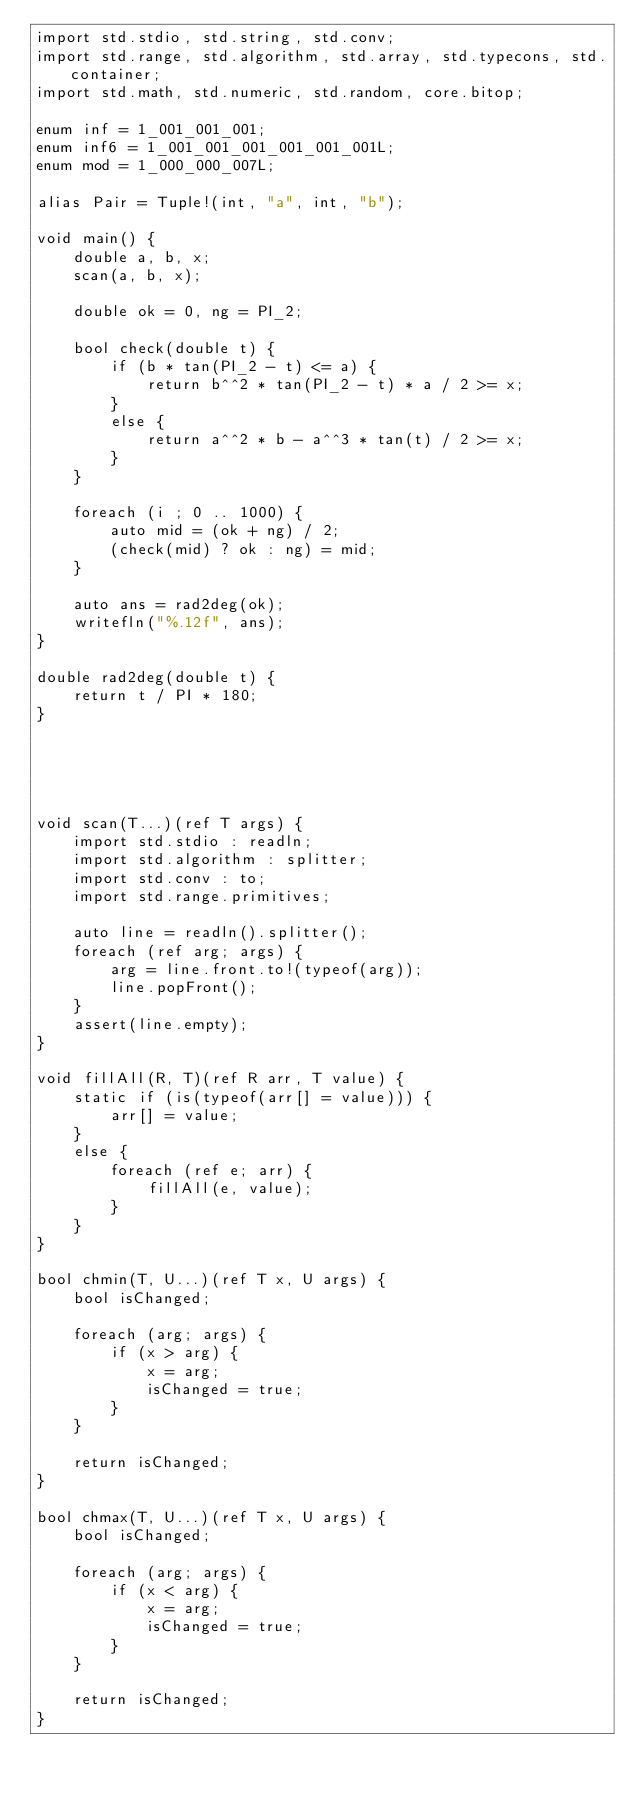Convert code to text. <code><loc_0><loc_0><loc_500><loc_500><_D_>import std.stdio, std.string, std.conv;
import std.range, std.algorithm, std.array, std.typecons, std.container;
import std.math, std.numeric, std.random, core.bitop;

enum inf = 1_001_001_001;
enum inf6 = 1_001_001_001_001_001_001L;
enum mod = 1_000_000_007L;

alias Pair = Tuple!(int, "a", int, "b");

void main() {
    double a, b, x;
    scan(a, b, x);

    double ok = 0, ng = PI_2;

    bool check(double t) {
        if (b * tan(PI_2 - t) <= a) {
            return b^^2 * tan(PI_2 - t) * a / 2 >= x;
        }
        else {
            return a^^2 * b - a^^3 * tan(t) / 2 >= x;
        }
    }

    foreach (i ; 0 .. 1000) {
        auto mid = (ok + ng) / 2;
        (check(mid) ? ok : ng) = mid;
    }

    auto ans = rad2deg(ok);
    writefln("%.12f", ans);
}

double rad2deg(double t) {
    return t / PI * 180;
}





void scan(T...)(ref T args) {
    import std.stdio : readln;
    import std.algorithm : splitter;
    import std.conv : to;
    import std.range.primitives;

    auto line = readln().splitter();
    foreach (ref arg; args) {
        arg = line.front.to!(typeof(arg));
        line.popFront();
    }
    assert(line.empty);
}

void fillAll(R, T)(ref R arr, T value) {
    static if (is(typeof(arr[] = value))) {
        arr[] = value;
    }
    else {
        foreach (ref e; arr) {
            fillAll(e, value);
        }
    }
}

bool chmin(T, U...)(ref T x, U args) {
    bool isChanged;

    foreach (arg; args) {
        if (x > arg) {
            x = arg;
            isChanged = true;
        }
    }

    return isChanged;
}

bool chmax(T, U...)(ref T x, U args) {
    bool isChanged;

    foreach (arg; args) {
        if (x < arg) {
            x = arg;
            isChanged = true;
        }
    }

    return isChanged;
}
</code> 